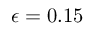Convert formula to latex. <formula><loc_0><loc_0><loc_500><loc_500>\epsilon = 0 . 1 5</formula> 